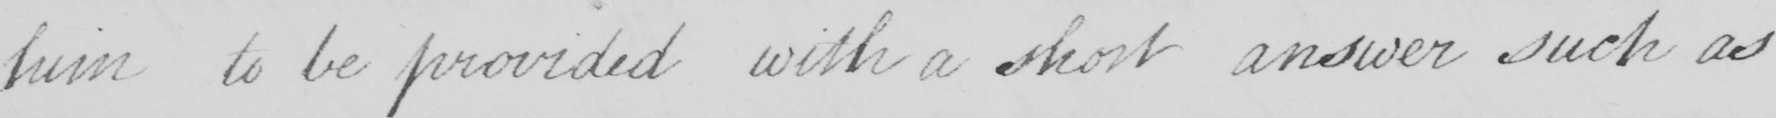What does this handwritten line say? him to be provided with a short answer such as 